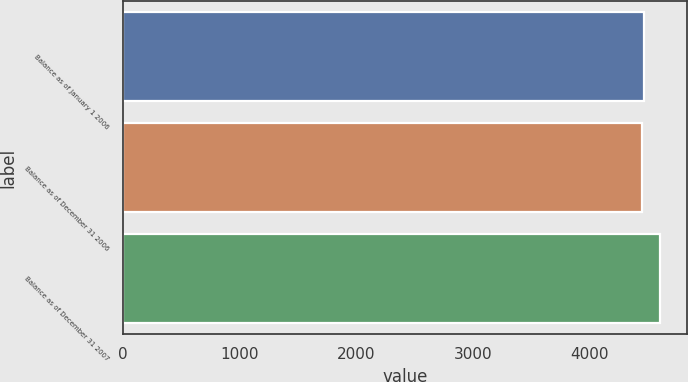Convert chart to OTSL. <chart><loc_0><loc_0><loc_500><loc_500><bar_chart><fcel>Balance as of January 1 2006<fcel>Balance as of December 31 2006<fcel>Balance as of December 31 2007<nl><fcel>4460.8<fcel>4445<fcel>4603<nl></chart> 